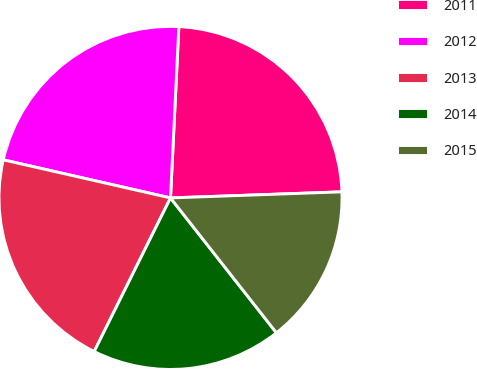Convert chart to OTSL. <chart><loc_0><loc_0><loc_500><loc_500><pie_chart><fcel>2011<fcel>2012<fcel>2013<fcel>2014<fcel>2015<nl><fcel>23.66%<fcel>22.21%<fcel>21.23%<fcel>17.93%<fcel>14.97%<nl></chart> 